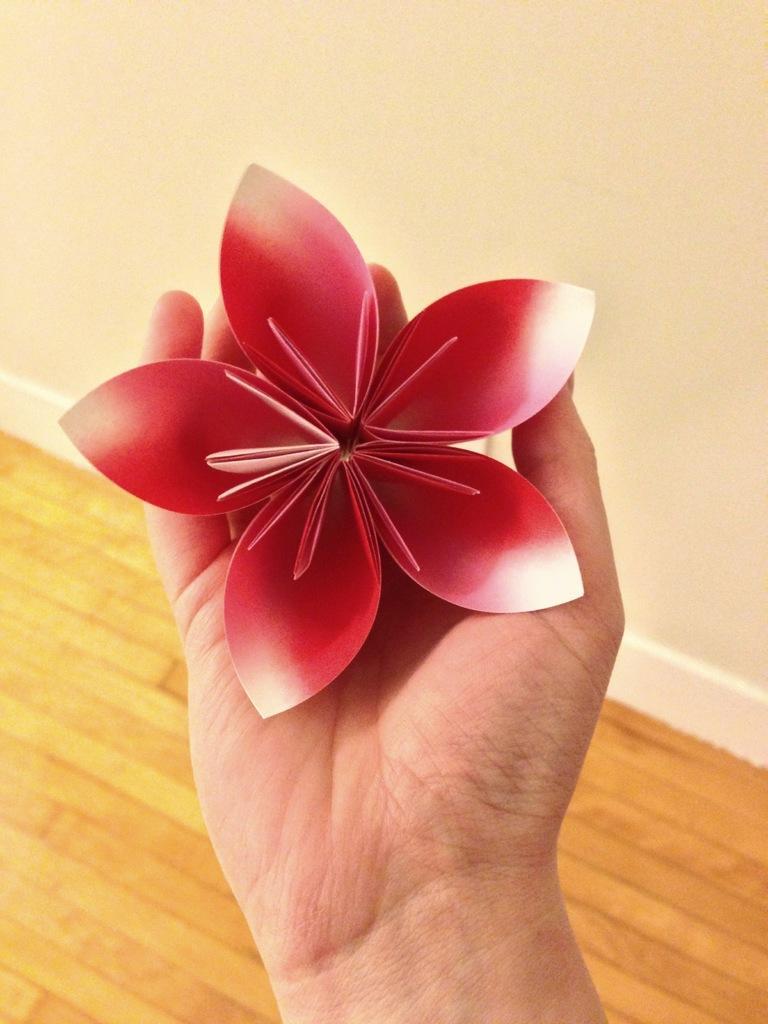Describe this image in one or two sentences. In this image we can see a person's hand holding a red color paper rose. In the background of the image we can see wooden floor and the wall in white color. 